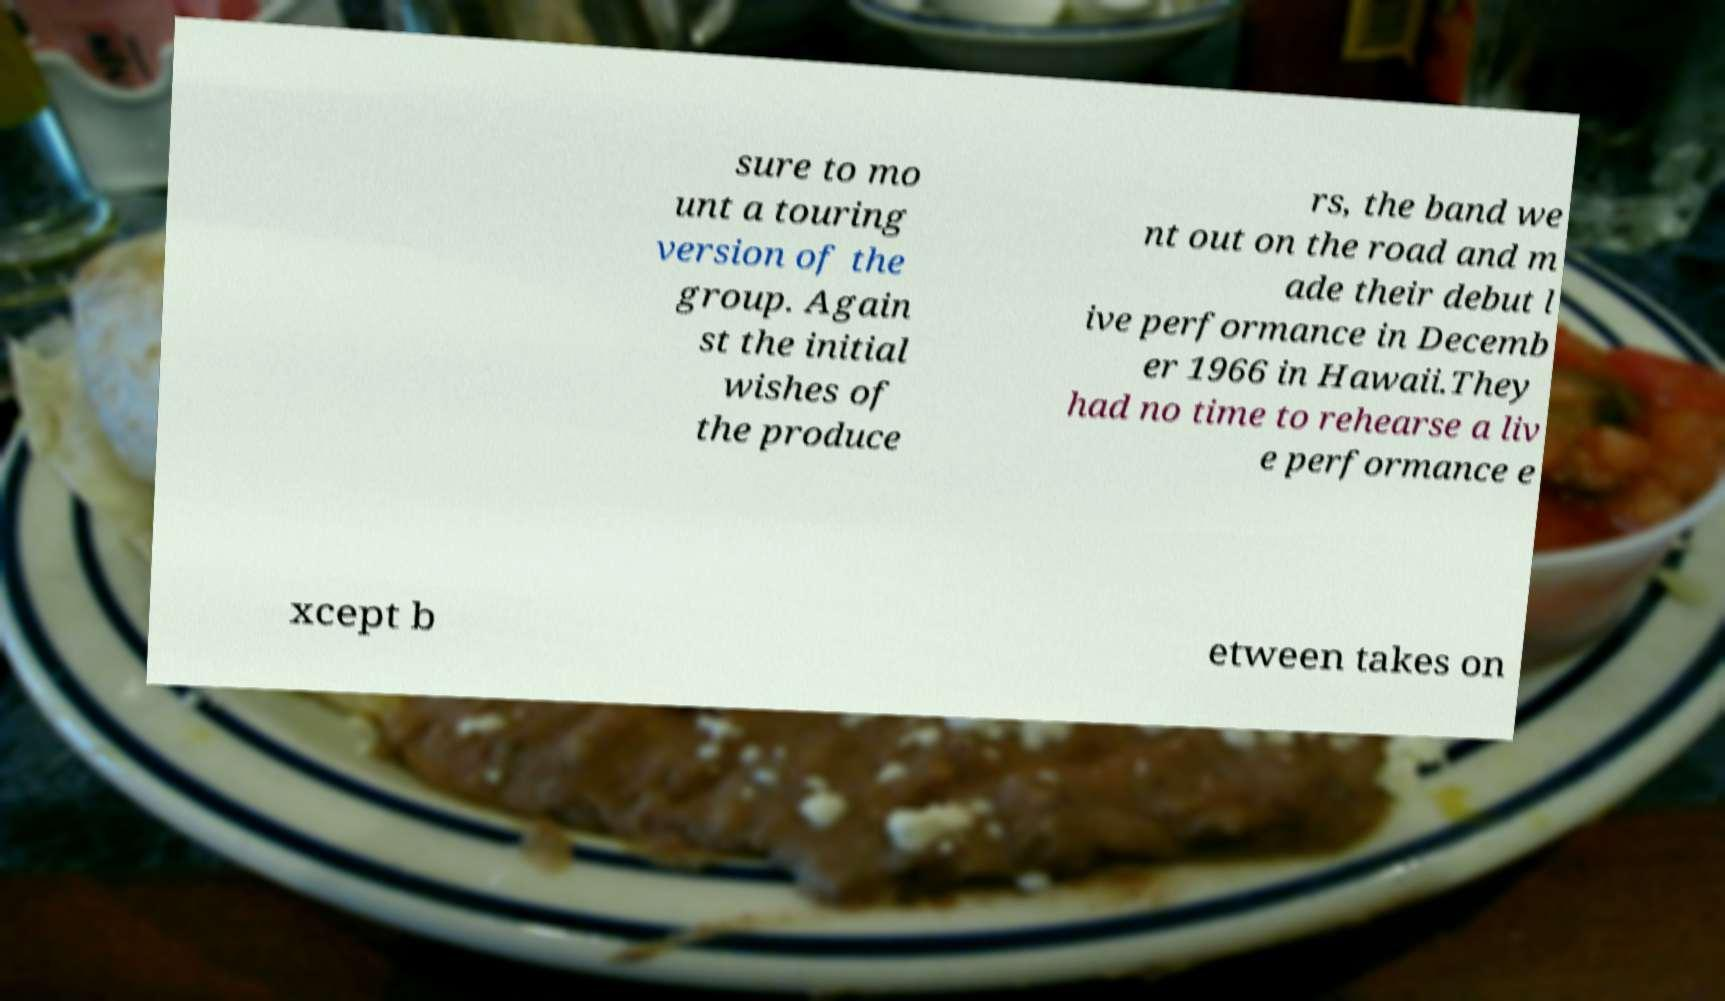There's text embedded in this image that I need extracted. Can you transcribe it verbatim? sure to mo unt a touring version of the group. Again st the initial wishes of the produce rs, the band we nt out on the road and m ade their debut l ive performance in Decemb er 1966 in Hawaii.They had no time to rehearse a liv e performance e xcept b etween takes on 